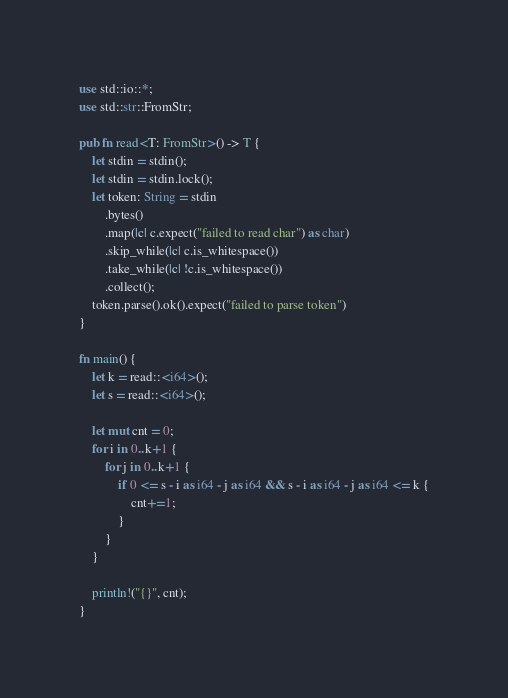<code> <loc_0><loc_0><loc_500><loc_500><_Rust_>use std::io::*;
use std::str::FromStr;

pub fn read<T: FromStr>() -> T {
    let stdin = stdin();
    let stdin = stdin.lock();
    let token: String = stdin
        .bytes()
        .map(|c| c.expect("failed to read char") as char)
        .skip_while(|c| c.is_whitespace())
        .take_while(|c| !c.is_whitespace())
        .collect();
    token.parse().ok().expect("failed to parse token")
}

fn main() {
    let k = read::<i64>();
    let s = read::<i64>();

    let mut cnt = 0;
    for i in 0..k+1 {
        for j in 0..k+1 {
            if 0 <= s - i as i64 - j as i64 && s - i as i64 - j as i64 <= k {
                cnt+=1;
            }
        }
    }
    
    println!("{}", cnt);
}
</code> 